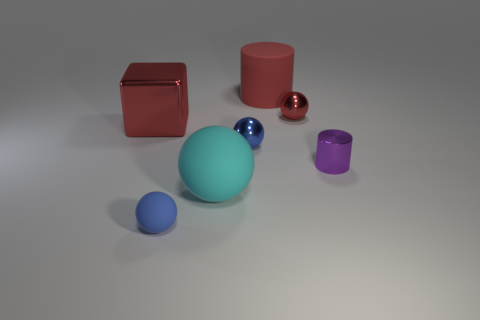How many tiny blue metal balls are there? There is one tiny blue metal ball in the image among other objects of various sizes and colors. 